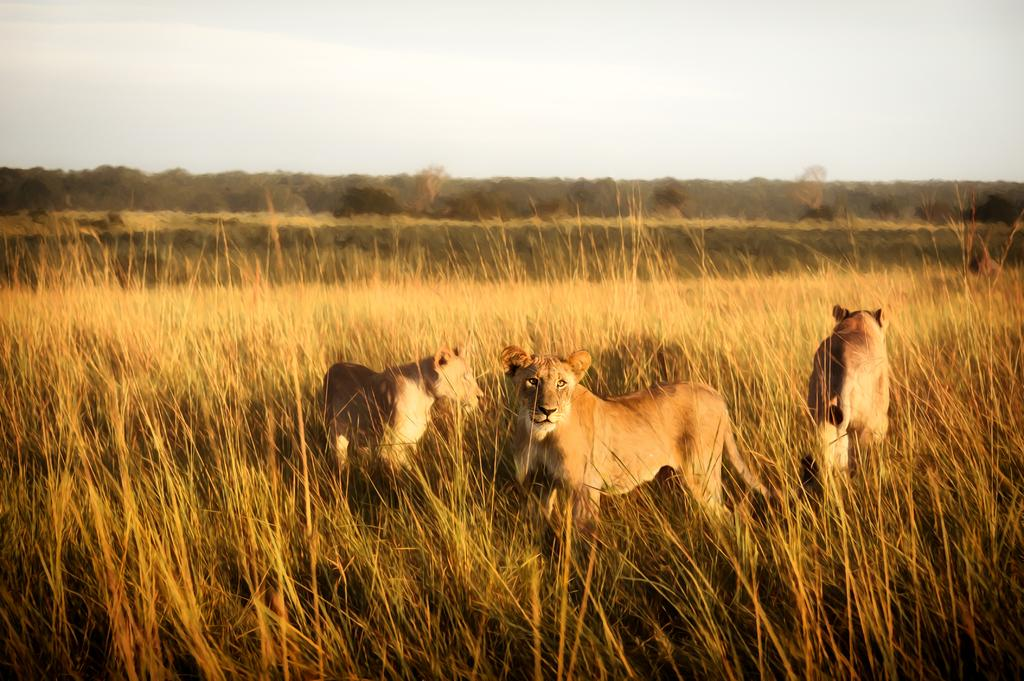What type of vegetation is present in the image? There is grass in the image. What other living beings can be seen in the image? There are animals in the image. What can be seen in the distance in the image? There are trees in the background of the image. What is visible at the top of the image? The sky is visible at the top of the image. Where is the playground located in the image? There is no playground present in the image. Can you tell me if the mom is sleeping in the image? There is no reference to a mom or sleeping in the image. 